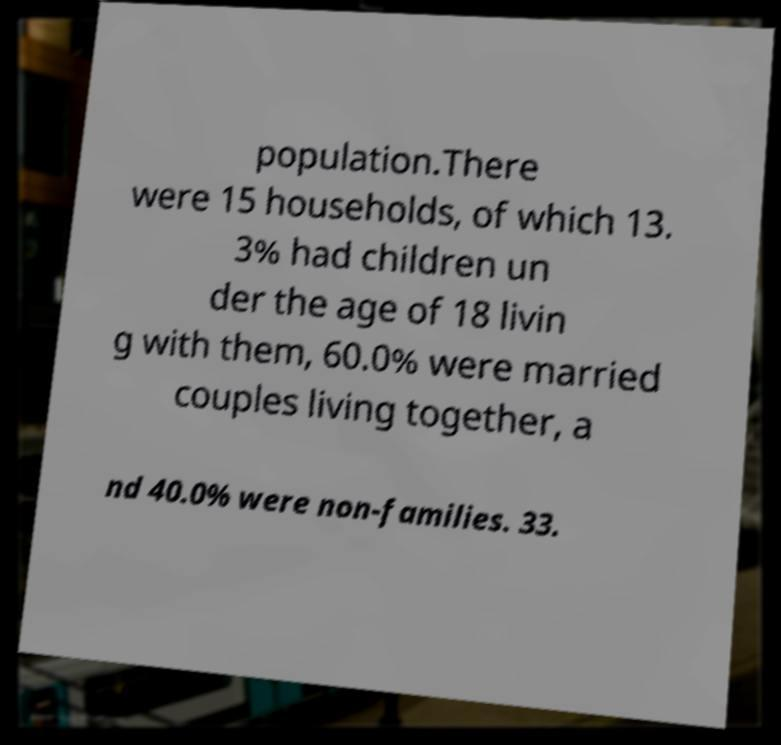Could you assist in decoding the text presented in this image and type it out clearly? population.There were 15 households, of which 13. 3% had children un der the age of 18 livin g with them, 60.0% were married couples living together, a nd 40.0% were non-families. 33. 